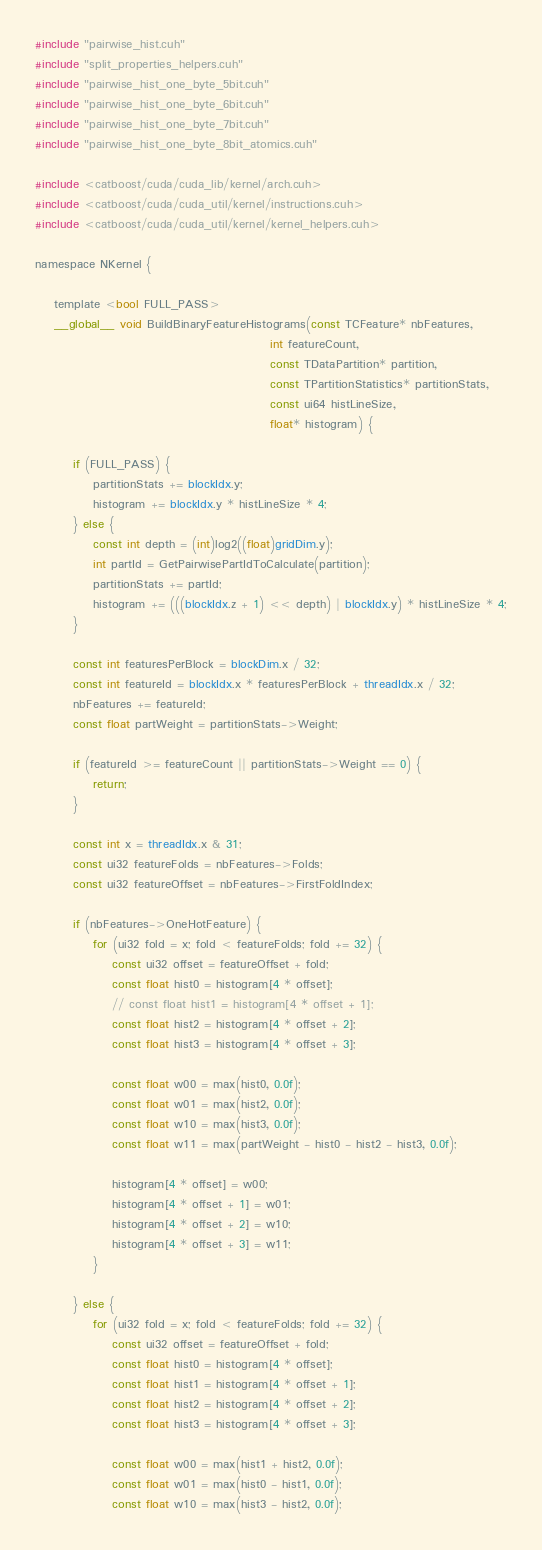<code> <loc_0><loc_0><loc_500><loc_500><_Cuda_>#include "pairwise_hist.cuh"
#include "split_properties_helpers.cuh"
#include "pairwise_hist_one_byte_5bit.cuh"
#include "pairwise_hist_one_byte_6bit.cuh"
#include "pairwise_hist_one_byte_7bit.cuh"
#include "pairwise_hist_one_byte_8bit_atomics.cuh"

#include <catboost/cuda/cuda_lib/kernel/arch.cuh>
#include <catboost/cuda/cuda_util/kernel/instructions.cuh>
#include <catboost/cuda/cuda_util/kernel/kernel_helpers.cuh>

namespace NKernel {

    template <bool FULL_PASS>
    __global__ void BuildBinaryFeatureHistograms(const TCFeature* nbFeatures,
                                                 int featureCount,
                                                 const TDataPartition* partition,
                                                 const TPartitionStatistics* partitionStats,
                                                 const ui64 histLineSize,
                                                 float* histogram) {

        if (FULL_PASS) {
            partitionStats += blockIdx.y;
            histogram += blockIdx.y * histLineSize * 4;
        } else {
            const int depth = (int)log2((float)gridDim.y);
            int partId = GetPairwisePartIdToCalculate(partition);
            partitionStats += partId;
            histogram += (((blockIdx.z + 1) << depth) | blockIdx.y) * histLineSize * 4;
        }

        const int featuresPerBlock = blockDim.x / 32;
        const int featureId = blockIdx.x * featuresPerBlock + threadIdx.x / 32;
        nbFeatures += featureId;
        const float partWeight = partitionStats->Weight;

        if (featureId >= featureCount || partitionStats->Weight == 0) {
            return;
        }

        const int x = threadIdx.x & 31;
        const ui32 featureFolds = nbFeatures->Folds;
        const ui32 featureOffset = nbFeatures->FirstFoldIndex;

        if (nbFeatures->OneHotFeature) {
            for (ui32 fold = x; fold < featureFolds; fold += 32) {
                const ui32 offset = featureOffset + fold;
                const float hist0 = histogram[4 * offset];
                // const float hist1 = histogram[4 * offset + 1];
                const float hist2 = histogram[4 * offset + 2];
                const float hist3 = histogram[4 * offset + 3];

                const float w00 = max(hist0, 0.0f);
                const float w01 = max(hist2, 0.0f);
                const float w10 = max(hist3, 0.0f);
                const float w11 = max(partWeight - hist0 - hist2 - hist3, 0.0f);

                histogram[4 * offset] = w00;
                histogram[4 * offset + 1] = w01;
                histogram[4 * offset + 2] = w10;
                histogram[4 * offset + 3] = w11;
            }

        } else {
            for (ui32 fold = x; fold < featureFolds; fold += 32) {
                const ui32 offset = featureOffset + fold;
                const float hist0 = histogram[4 * offset];
                const float hist1 = histogram[4 * offset + 1];
                const float hist2 = histogram[4 * offset + 2];
                const float hist3 = histogram[4 * offset + 3];

                const float w00 = max(hist1 + hist2, 0.0f);
                const float w01 = max(hist0 - hist1, 0.0f);
                const float w10 = max(hist3 - hist2, 0.0f);</code> 